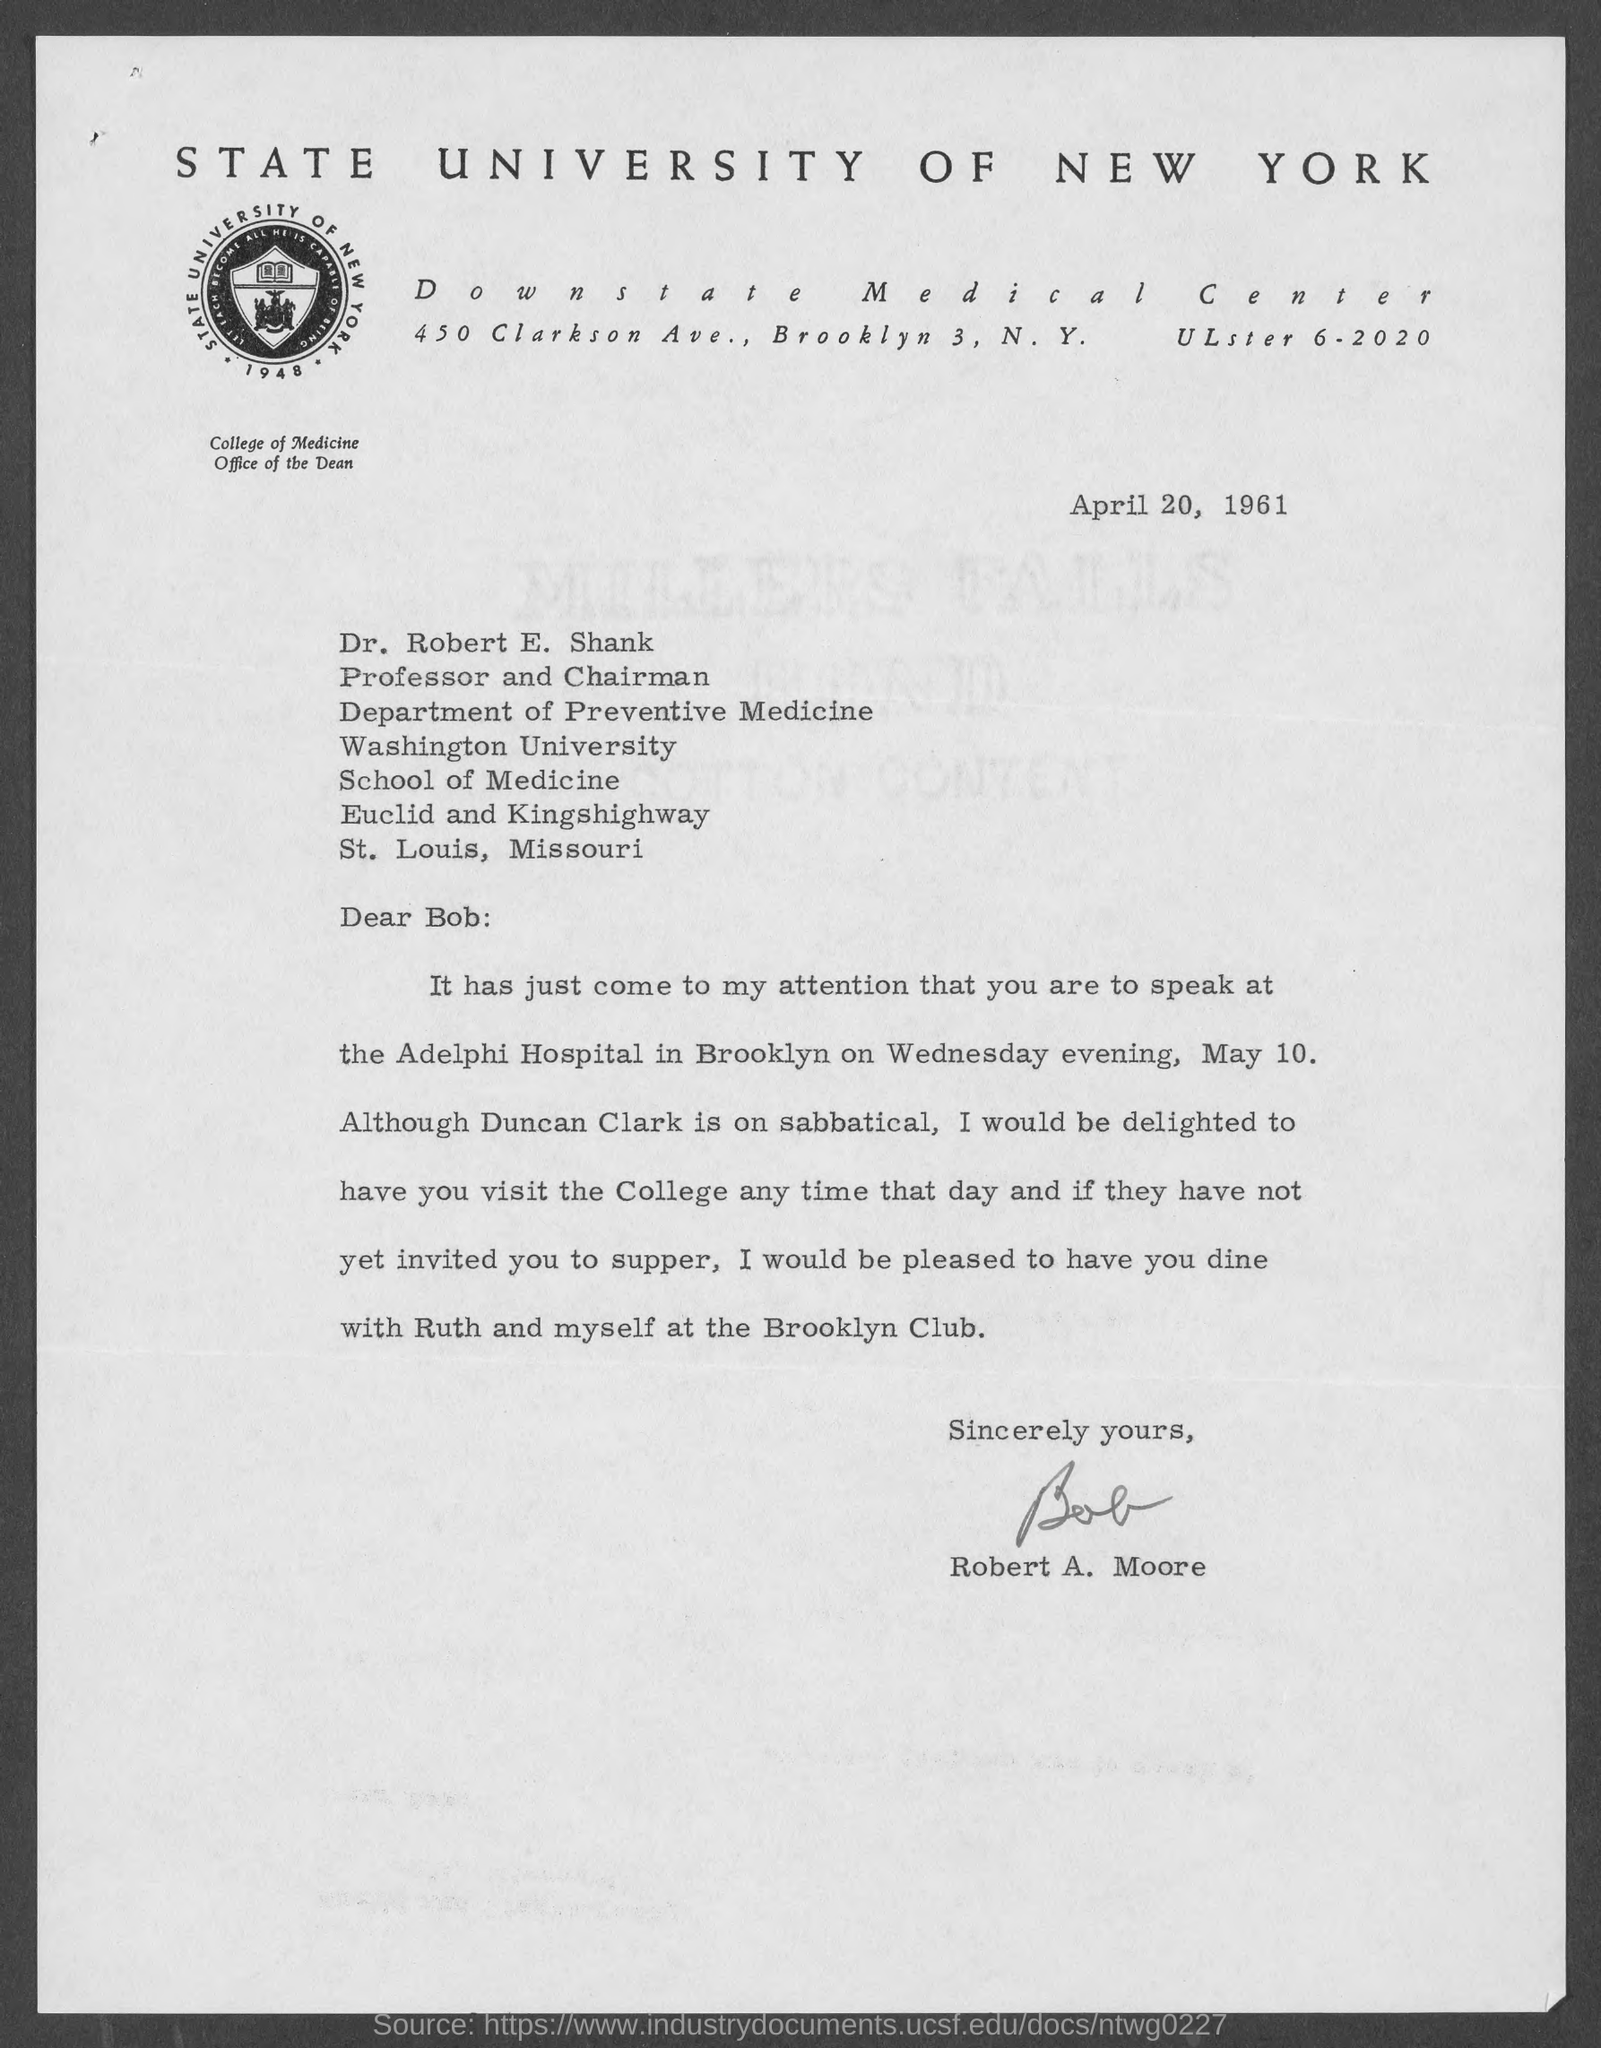When is the Memorandum dated on ?
Your response must be concise. April 20, 1961. 